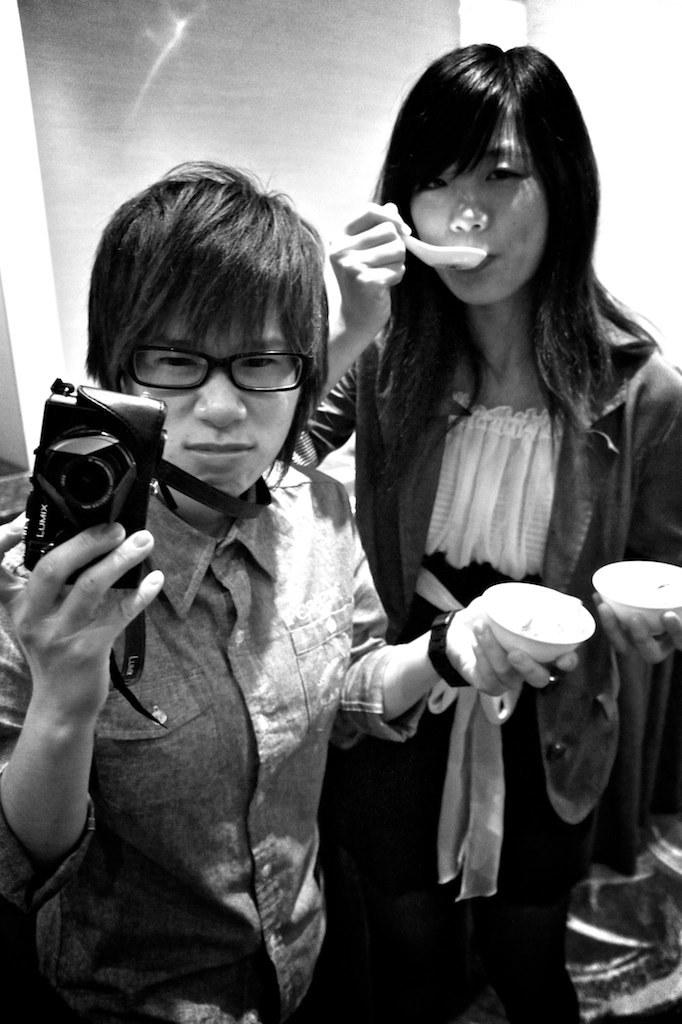How many people are in the image? There are two people in the image. Can you describe the gender of the people? One of the people is a man, and the other person is a woman. What is the man holding in the image? The man is holding a camera. What is the woman doing in the image? The woman is eating soup. What position are the tomatoes in the image? There are no tomatoes present in the image. How many times has the woman folded the napkin in the image? There is no mention of a napkin or folding in the image. 